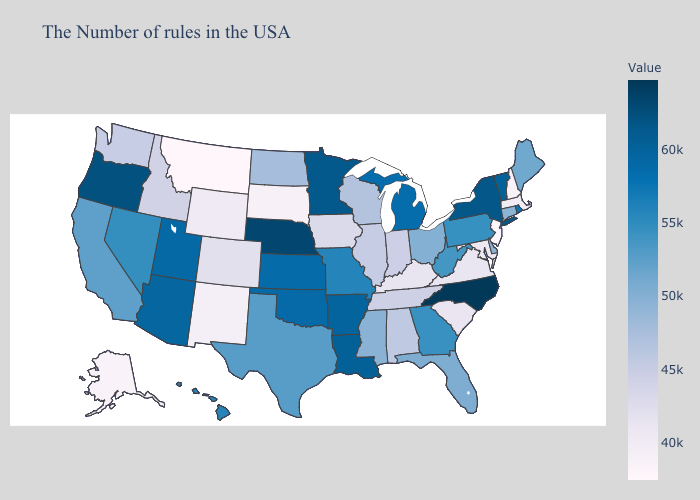Does Florida have the highest value in the South?
Keep it brief. No. Among the states that border Minnesota , does North Dakota have the highest value?
Be succinct. Yes. Does the map have missing data?
Short answer required. No. Among the states that border South Dakota , which have the highest value?
Keep it brief. Nebraska. 